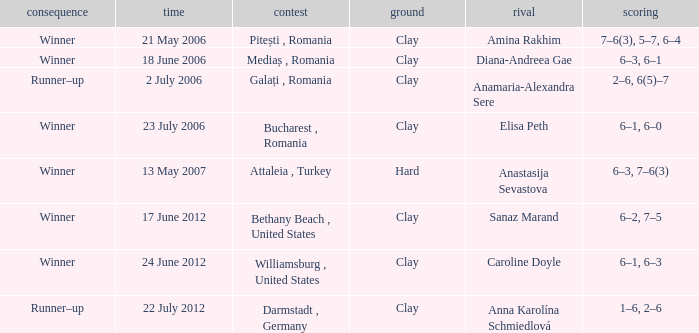What tournament was held on 21 May 2006? Pitești , Romania. 